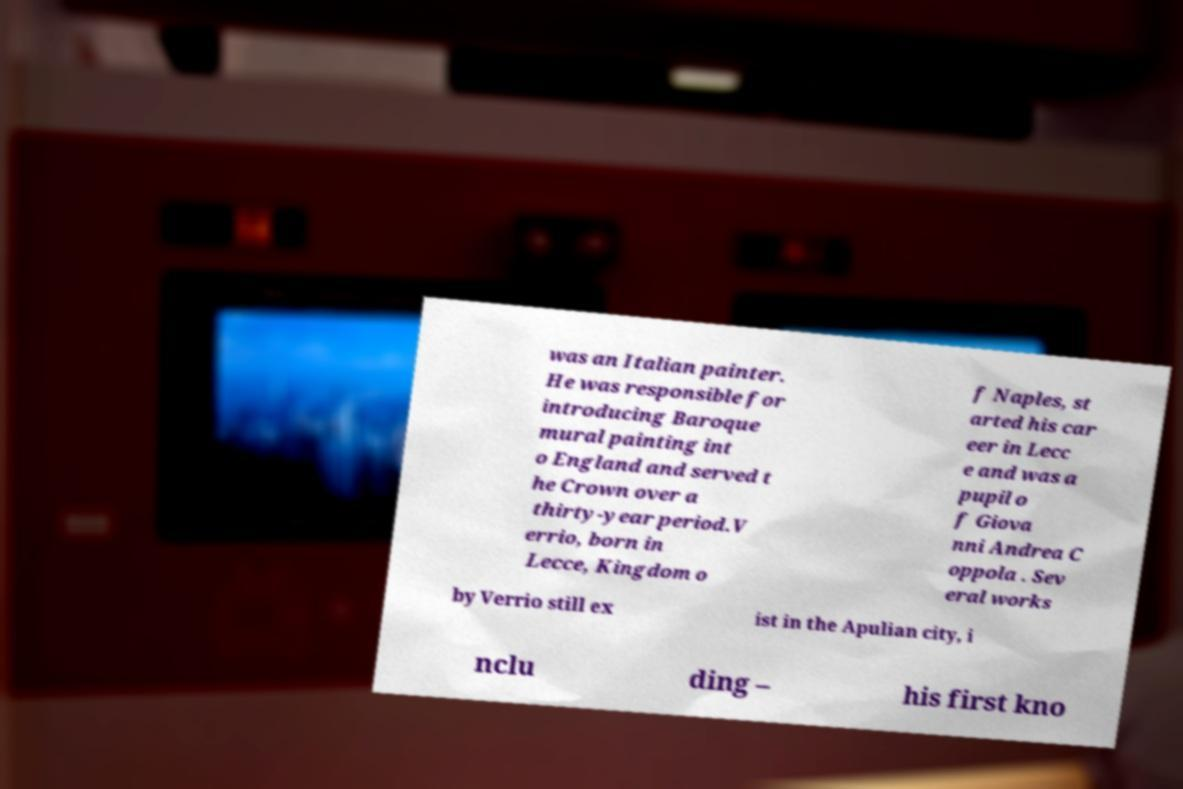Could you extract and type out the text from this image? was an Italian painter. He was responsible for introducing Baroque mural painting int o England and served t he Crown over a thirty-year period.V errio, born in Lecce, Kingdom o f Naples, st arted his car eer in Lecc e and was a pupil o f Giova nni Andrea C oppola . Sev eral works by Verrio still ex ist in the Apulian city, i nclu ding – his first kno 